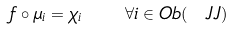<formula> <loc_0><loc_0><loc_500><loc_500>f \circ \mu _ { i } = \chi _ { i } \quad \forall i \in O b ( \ J J )</formula> 